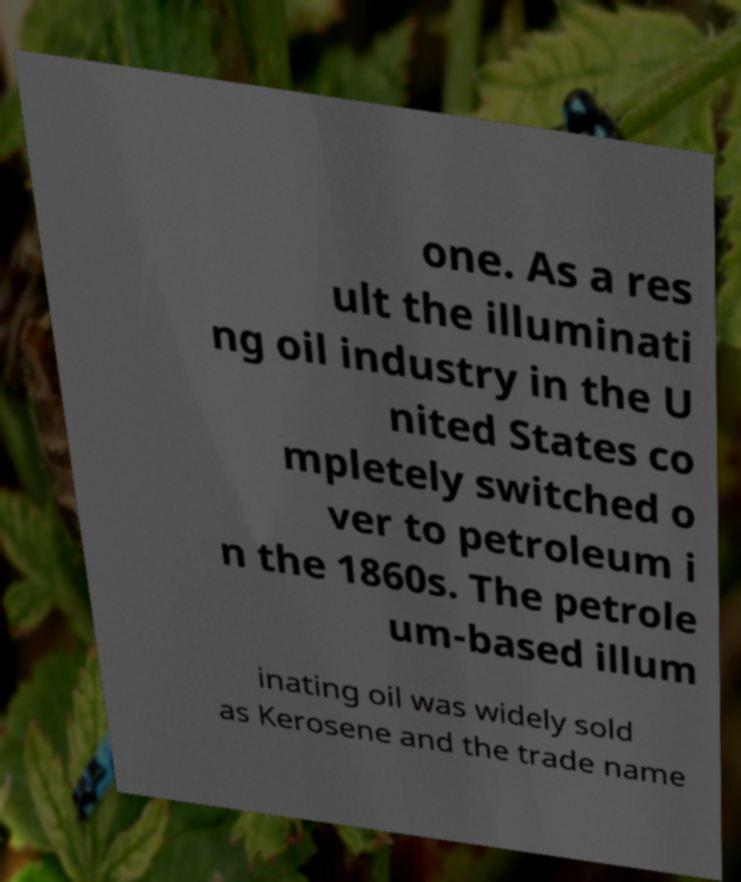Could you extract and type out the text from this image? one. As a res ult the illuminati ng oil industry in the U nited States co mpletely switched o ver to petroleum i n the 1860s. The petrole um-based illum inating oil was widely sold as Kerosene and the trade name 